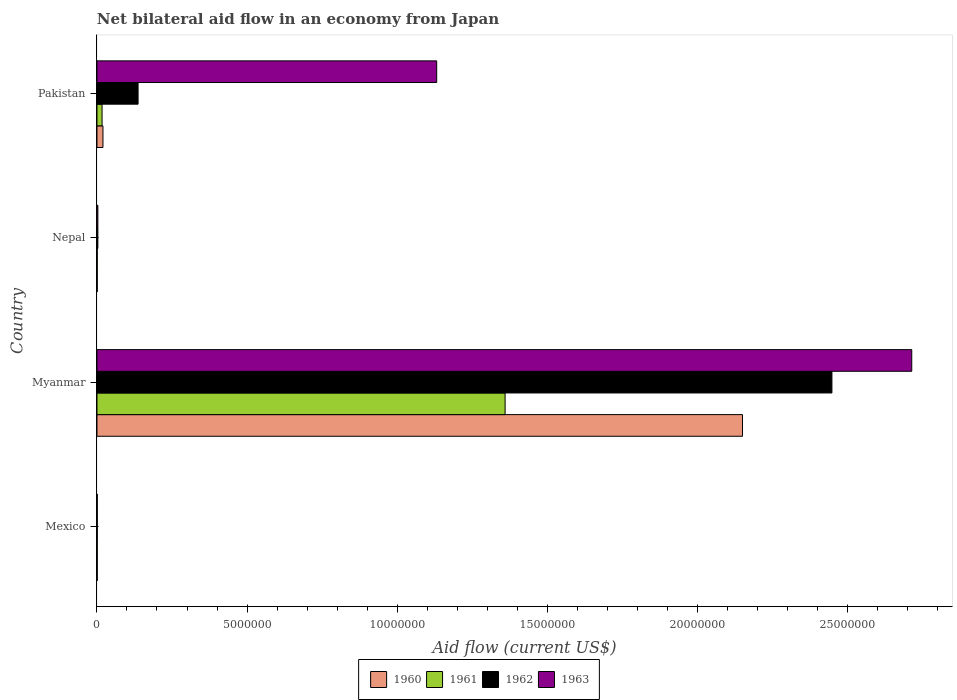How many groups of bars are there?
Your answer should be compact. 4. Are the number of bars on each tick of the Y-axis equal?
Give a very brief answer. Yes. What is the net bilateral aid flow in 1961 in Nepal?
Keep it short and to the point. 10000. Across all countries, what is the maximum net bilateral aid flow in 1963?
Provide a succinct answer. 2.72e+07. In which country was the net bilateral aid flow in 1962 maximum?
Provide a succinct answer. Myanmar. What is the total net bilateral aid flow in 1960 in the graph?
Give a very brief answer. 2.17e+07. What is the difference between the net bilateral aid flow in 1961 in Myanmar and that in Pakistan?
Give a very brief answer. 1.34e+07. What is the difference between the net bilateral aid flow in 1962 in Myanmar and the net bilateral aid flow in 1961 in Pakistan?
Your answer should be compact. 2.43e+07. What is the average net bilateral aid flow in 1960 per country?
Your answer should be very brief. 5.43e+06. What is the difference between the net bilateral aid flow in 1962 and net bilateral aid flow in 1963 in Myanmar?
Your response must be concise. -2.66e+06. In how many countries, is the net bilateral aid flow in 1963 greater than 7000000 US$?
Keep it short and to the point. 2. What is the ratio of the net bilateral aid flow in 1961 in Mexico to that in Nepal?
Provide a succinct answer. 1. What is the difference between the highest and the second highest net bilateral aid flow in 1961?
Your response must be concise. 1.34e+07. What is the difference between the highest and the lowest net bilateral aid flow in 1962?
Your answer should be compact. 2.45e+07. In how many countries, is the net bilateral aid flow in 1960 greater than the average net bilateral aid flow in 1960 taken over all countries?
Your answer should be compact. 1. Is the sum of the net bilateral aid flow in 1961 in Mexico and Nepal greater than the maximum net bilateral aid flow in 1962 across all countries?
Your response must be concise. No. Is it the case that in every country, the sum of the net bilateral aid flow in 1963 and net bilateral aid flow in 1961 is greater than the sum of net bilateral aid flow in 1962 and net bilateral aid flow in 1960?
Make the answer very short. No. What does the 3rd bar from the bottom in Nepal represents?
Provide a succinct answer. 1962. Is it the case that in every country, the sum of the net bilateral aid flow in 1961 and net bilateral aid flow in 1960 is greater than the net bilateral aid flow in 1962?
Offer a very short reply. No. How many bars are there?
Your answer should be very brief. 16. Are all the bars in the graph horizontal?
Your answer should be very brief. Yes. What is the difference between two consecutive major ticks on the X-axis?
Your response must be concise. 5.00e+06. Does the graph contain grids?
Offer a very short reply. No. What is the title of the graph?
Provide a succinct answer. Net bilateral aid flow in an economy from Japan. Does "2010" appear as one of the legend labels in the graph?
Offer a terse response. No. What is the Aid flow (current US$) of 1960 in Mexico?
Provide a succinct answer. 10000. What is the Aid flow (current US$) in 1961 in Mexico?
Ensure brevity in your answer.  10000. What is the Aid flow (current US$) of 1962 in Mexico?
Make the answer very short. 10000. What is the Aid flow (current US$) of 1960 in Myanmar?
Provide a short and direct response. 2.15e+07. What is the Aid flow (current US$) of 1961 in Myanmar?
Keep it short and to the point. 1.36e+07. What is the Aid flow (current US$) of 1962 in Myanmar?
Offer a very short reply. 2.45e+07. What is the Aid flow (current US$) in 1963 in Myanmar?
Give a very brief answer. 2.72e+07. What is the Aid flow (current US$) in 1961 in Nepal?
Make the answer very short. 10000. What is the Aid flow (current US$) of 1961 in Pakistan?
Offer a very short reply. 1.70e+05. What is the Aid flow (current US$) of 1962 in Pakistan?
Your answer should be compact. 1.37e+06. What is the Aid flow (current US$) in 1963 in Pakistan?
Your answer should be compact. 1.13e+07. Across all countries, what is the maximum Aid flow (current US$) of 1960?
Offer a terse response. 2.15e+07. Across all countries, what is the maximum Aid flow (current US$) in 1961?
Provide a short and direct response. 1.36e+07. Across all countries, what is the maximum Aid flow (current US$) of 1962?
Your answer should be very brief. 2.45e+07. Across all countries, what is the maximum Aid flow (current US$) in 1963?
Offer a very short reply. 2.72e+07. Across all countries, what is the minimum Aid flow (current US$) of 1961?
Your answer should be very brief. 10000. Across all countries, what is the minimum Aid flow (current US$) of 1962?
Your response must be concise. 10000. Across all countries, what is the minimum Aid flow (current US$) in 1963?
Give a very brief answer. 10000. What is the total Aid flow (current US$) of 1960 in the graph?
Your answer should be compact. 2.17e+07. What is the total Aid flow (current US$) of 1961 in the graph?
Ensure brevity in your answer.  1.38e+07. What is the total Aid flow (current US$) in 1962 in the graph?
Your answer should be compact. 2.59e+07. What is the total Aid flow (current US$) of 1963 in the graph?
Give a very brief answer. 3.85e+07. What is the difference between the Aid flow (current US$) in 1960 in Mexico and that in Myanmar?
Offer a terse response. -2.15e+07. What is the difference between the Aid flow (current US$) of 1961 in Mexico and that in Myanmar?
Your answer should be very brief. -1.36e+07. What is the difference between the Aid flow (current US$) in 1962 in Mexico and that in Myanmar?
Offer a very short reply. -2.45e+07. What is the difference between the Aid flow (current US$) of 1963 in Mexico and that in Myanmar?
Provide a short and direct response. -2.71e+07. What is the difference between the Aid flow (current US$) in 1960 in Mexico and that in Nepal?
Give a very brief answer. 0. What is the difference between the Aid flow (current US$) in 1963 in Mexico and that in Nepal?
Give a very brief answer. -2.00e+04. What is the difference between the Aid flow (current US$) of 1961 in Mexico and that in Pakistan?
Keep it short and to the point. -1.60e+05. What is the difference between the Aid flow (current US$) in 1962 in Mexico and that in Pakistan?
Offer a terse response. -1.36e+06. What is the difference between the Aid flow (current US$) in 1963 in Mexico and that in Pakistan?
Give a very brief answer. -1.13e+07. What is the difference between the Aid flow (current US$) in 1960 in Myanmar and that in Nepal?
Your answer should be very brief. 2.15e+07. What is the difference between the Aid flow (current US$) in 1961 in Myanmar and that in Nepal?
Your answer should be very brief. 1.36e+07. What is the difference between the Aid flow (current US$) in 1962 in Myanmar and that in Nepal?
Give a very brief answer. 2.45e+07. What is the difference between the Aid flow (current US$) of 1963 in Myanmar and that in Nepal?
Offer a terse response. 2.71e+07. What is the difference between the Aid flow (current US$) of 1960 in Myanmar and that in Pakistan?
Your response must be concise. 2.13e+07. What is the difference between the Aid flow (current US$) in 1961 in Myanmar and that in Pakistan?
Offer a terse response. 1.34e+07. What is the difference between the Aid flow (current US$) of 1962 in Myanmar and that in Pakistan?
Give a very brief answer. 2.31e+07. What is the difference between the Aid flow (current US$) in 1963 in Myanmar and that in Pakistan?
Offer a very short reply. 1.58e+07. What is the difference between the Aid flow (current US$) in 1960 in Nepal and that in Pakistan?
Make the answer very short. -1.90e+05. What is the difference between the Aid flow (current US$) in 1962 in Nepal and that in Pakistan?
Your response must be concise. -1.34e+06. What is the difference between the Aid flow (current US$) of 1963 in Nepal and that in Pakistan?
Offer a very short reply. -1.13e+07. What is the difference between the Aid flow (current US$) in 1960 in Mexico and the Aid flow (current US$) in 1961 in Myanmar?
Offer a terse response. -1.36e+07. What is the difference between the Aid flow (current US$) in 1960 in Mexico and the Aid flow (current US$) in 1962 in Myanmar?
Provide a succinct answer. -2.45e+07. What is the difference between the Aid flow (current US$) in 1960 in Mexico and the Aid flow (current US$) in 1963 in Myanmar?
Your answer should be compact. -2.71e+07. What is the difference between the Aid flow (current US$) of 1961 in Mexico and the Aid flow (current US$) of 1962 in Myanmar?
Offer a very short reply. -2.45e+07. What is the difference between the Aid flow (current US$) in 1961 in Mexico and the Aid flow (current US$) in 1963 in Myanmar?
Give a very brief answer. -2.71e+07. What is the difference between the Aid flow (current US$) of 1962 in Mexico and the Aid flow (current US$) of 1963 in Myanmar?
Offer a terse response. -2.71e+07. What is the difference between the Aid flow (current US$) of 1960 in Mexico and the Aid flow (current US$) of 1962 in Nepal?
Your response must be concise. -2.00e+04. What is the difference between the Aid flow (current US$) in 1960 in Mexico and the Aid flow (current US$) in 1963 in Nepal?
Your answer should be very brief. -2.00e+04. What is the difference between the Aid flow (current US$) in 1960 in Mexico and the Aid flow (current US$) in 1962 in Pakistan?
Make the answer very short. -1.36e+06. What is the difference between the Aid flow (current US$) in 1960 in Mexico and the Aid flow (current US$) in 1963 in Pakistan?
Make the answer very short. -1.13e+07. What is the difference between the Aid flow (current US$) of 1961 in Mexico and the Aid flow (current US$) of 1962 in Pakistan?
Provide a succinct answer. -1.36e+06. What is the difference between the Aid flow (current US$) in 1961 in Mexico and the Aid flow (current US$) in 1963 in Pakistan?
Offer a terse response. -1.13e+07. What is the difference between the Aid flow (current US$) in 1962 in Mexico and the Aid flow (current US$) in 1963 in Pakistan?
Ensure brevity in your answer.  -1.13e+07. What is the difference between the Aid flow (current US$) in 1960 in Myanmar and the Aid flow (current US$) in 1961 in Nepal?
Ensure brevity in your answer.  2.15e+07. What is the difference between the Aid flow (current US$) of 1960 in Myanmar and the Aid flow (current US$) of 1962 in Nepal?
Give a very brief answer. 2.15e+07. What is the difference between the Aid flow (current US$) of 1960 in Myanmar and the Aid flow (current US$) of 1963 in Nepal?
Keep it short and to the point. 2.15e+07. What is the difference between the Aid flow (current US$) of 1961 in Myanmar and the Aid flow (current US$) of 1962 in Nepal?
Your answer should be very brief. 1.36e+07. What is the difference between the Aid flow (current US$) in 1961 in Myanmar and the Aid flow (current US$) in 1963 in Nepal?
Ensure brevity in your answer.  1.36e+07. What is the difference between the Aid flow (current US$) in 1962 in Myanmar and the Aid flow (current US$) in 1963 in Nepal?
Provide a succinct answer. 2.45e+07. What is the difference between the Aid flow (current US$) in 1960 in Myanmar and the Aid flow (current US$) in 1961 in Pakistan?
Make the answer very short. 2.13e+07. What is the difference between the Aid flow (current US$) in 1960 in Myanmar and the Aid flow (current US$) in 1962 in Pakistan?
Provide a short and direct response. 2.01e+07. What is the difference between the Aid flow (current US$) in 1960 in Myanmar and the Aid flow (current US$) in 1963 in Pakistan?
Your answer should be compact. 1.02e+07. What is the difference between the Aid flow (current US$) in 1961 in Myanmar and the Aid flow (current US$) in 1962 in Pakistan?
Your answer should be compact. 1.22e+07. What is the difference between the Aid flow (current US$) of 1961 in Myanmar and the Aid flow (current US$) of 1963 in Pakistan?
Provide a succinct answer. 2.28e+06. What is the difference between the Aid flow (current US$) in 1962 in Myanmar and the Aid flow (current US$) in 1963 in Pakistan?
Your answer should be very brief. 1.32e+07. What is the difference between the Aid flow (current US$) in 1960 in Nepal and the Aid flow (current US$) in 1962 in Pakistan?
Offer a terse response. -1.36e+06. What is the difference between the Aid flow (current US$) of 1960 in Nepal and the Aid flow (current US$) of 1963 in Pakistan?
Keep it short and to the point. -1.13e+07. What is the difference between the Aid flow (current US$) of 1961 in Nepal and the Aid flow (current US$) of 1962 in Pakistan?
Offer a terse response. -1.36e+06. What is the difference between the Aid flow (current US$) in 1961 in Nepal and the Aid flow (current US$) in 1963 in Pakistan?
Make the answer very short. -1.13e+07. What is the difference between the Aid flow (current US$) in 1962 in Nepal and the Aid flow (current US$) in 1963 in Pakistan?
Your answer should be very brief. -1.13e+07. What is the average Aid flow (current US$) in 1960 per country?
Your answer should be very brief. 5.43e+06. What is the average Aid flow (current US$) of 1961 per country?
Offer a terse response. 3.45e+06. What is the average Aid flow (current US$) of 1962 per country?
Make the answer very short. 6.48e+06. What is the average Aid flow (current US$) in 1963 per country?
Your response must be concise. 9.63e+06. What is the difference between the Aid flow (current US$) in 1960 and Aid flow (current US$) in 1961 in Myanmar?
Your response must be concise. 7.91e+06. What is the difference between the Aid flow (current US$) of 1960 and Aid flow (current US$) of 1962 in Myanmar?
Provide a succinct answer. -2.98e+06. What is the difference between the Aid flow (current US$) in 1960 and Aid flow (current US$) in 1963 in Myanmar?
Your response must be concise. -5.64e+06. What is the difference between the Aid flow (current US$) in 1961 and Aid flow (current US$) in 1962 in Myanmar?
Keep it short and to the point. -1.09e+07. What is the difference between the Aid flow (current US$) in 1961 and Aid flow (current US$) in 1963 in Myanmar?
Provide a short and direct response. -1.36e+07. What is the difference between the Aid flow (current US$) in 1962 and Aid flow (current US$) in 1963 in Myanmar?
Your answer should be very brief. -2.66e+06. What is the difference between the Aid flow (current US$) of 1960 and Aid flow (current US$) of 1961 in Nepal?
Provide a short and direct response. 0. What is the difference between the Aid flow (current US$) of 1960 and Aid flow (current US$) of 1962 in Nepal?
Your response must be concise. -2.00e+04. What is the difference between the Aid flow (current US$) of 1961 and Aid flow (current US$) of 1962 in Nepal?
Your response must be concise. -2.00e+04. What is the difference between the Aid flow (current US$) in 1961 and Aid flow (current US$) in 1963 in Nepal?
Your answer should be very brief. -2.00e+04. What is the difference between the Aid flow (current US$) in 1960 and Aid flow (current US$) in 1961 in Pakistan?
Your answer should be very brief. 3.00e+04. What is the difference between the Aid flow (current US$) of 1960 and Aid flow (current US$) of 1962 in Pakistan?
Give a very brief answer. -1.17e+06. What is the difference between the Aid flow (current US$) of 1960 and Aid flow (current US$) of 1963 in Pakistan?
Your response must be concise. -1.11e+07. What is the difference between the Aid flow (current US$) in 1961 and Aid flow (current US$) in 1962 in Pakistan?
Your response must be concise. -1.20e+06. What is the difference between the Aid flow (current US$) of 1961 and Aid flow (current US$) of 1963 in Pakistan?
Give a very brief answer. -1.12e+07. What is the difference between the Aid flow (current US$) in 1962 and Aid flow (current US$) in 1963 in Pakistan?
Your response must be concise. -9.95e+06. What is the ratio of the Aid flow (current US$) of 1960 in Mexico to that in Myanmar?
Offer a terse response. 0. What is the ratio of the Aid flow (current US$) of 1961 in Mexico to that in Myanmar?
Offer a terse response. 0. What is the ratio of the Aid flow (current US$) of 1960 in Mexico to that in Nepal?
Your response must be concise. 1. What is the ratio of the Aid flow (current US$) in 1961 in Mexico to that in Nepal?
Offer a very short reply. 1. What is the ratio of the Aid flow (current US$) in 1963 in Mexico to that in Nepal?
Make the answer very short. 0.33. What is the ratio of the Aid flow (current US$) in 1960 in Mexico to that in Pakistan?
Your answer should be compact. 0.05. What is the ratio of the Aid flow (current US$) of 1961 in Mexico to that in Pakistan?
Your answer should be compact. 0.06. What is the ratio of the Aid flow (current US$) of 1962 in Mexico to that in Pakistan?
Keep it short and to the point. 0.01. What is the ratio of the Aid flow (current US$) of 1963 in Mexico to that in Pakistan?
Provide a short and direct response. 0. What is the ratio of the Aid flow (current US$) of 1960 in Myanmar to that in Nepal?
Your response must be concise. 2151. What is the ratio of the Aid flow (current US$) of 1961 in Myanmar to that in Nepal?
Your answer should be very brief. 1360. What is the ratio of the Aid flow (current US$) in 1962 in Myanmar to that in Nepal?
Ensure brevity in your answer.  816.33. What is the ratio of the Aid flow (current US$) of 1963 in Myanmar to that in Nepal?
Provide a short and direct response. 905. What is the ratio of the Aid flow (current US$) in 1960 in Myanmar to that in Pakistan?
Offer a terse response. 107.55. What is the ratio of the Aid flow (current US$) of 1961 in Myanmar to that in Pakistan?
Offer a very short reply. 80. What is the ratio of the Aid flow (current US$) of 1962 in Myanmar to that in Pakistan?
Your answer should be compact. 17.88. What is the ratio of the Aid flow (current US$) in 1963 in Myanmar to that in Pakistan?
Your answer should be very brief. 2.4. What is the ratio of the Aid flow (current US$) of 1960 in Nepal to that in Pakistan?
Your answer should be compact. 0.05. What is the ratio of the Aid flow (current US$) of 1961 in Nepal to that in Pakistan?
Your response must be concise. 0.06. What is the ratio of the Aid flow (current US$) in 1962 in Nepal to that in Pakistan?
Offer a terse response. 0.02. What is the ratio of the Aid flow (current US$) in 1963 in Nepal to that in Pakistan?
Offer a terse response. 0. What is the difference between the highest and the second highest Aid flow (current US$) of 1960?
Make the answer very short. 2.13e+07. What is the difference between the highest and the second highest Aid flow (current US$) in 1961?
Keep it short and to the point. 1.34e+07. What is the difference between the highest and the second highest Aid flow (current US$) in 1962?
Your answer should be very brief. 2.31e+07. What is the difference between the highest and the second highest Aid flow (current US$) of 1963?
Your answer should be very brief. 1.58e+07. What is the difference between the highest and the lowest Aid flow (current US$) of 1960?
Ensure brevity in your answer.  2.15e+07. What is the difference between the highest and the lowest Aid flow (current US$) in 1961?
Ensure brevity in your answer.  1.36e+07. What is the difference between the highest and the lowest Aid flow (current US$) in 1962?
Provide a succinct answer. 2.45e+07. What is the difference between the highest and the lowest Aid flow (current US$) of 1963?
Offer a terse response. 2.71e+07. 